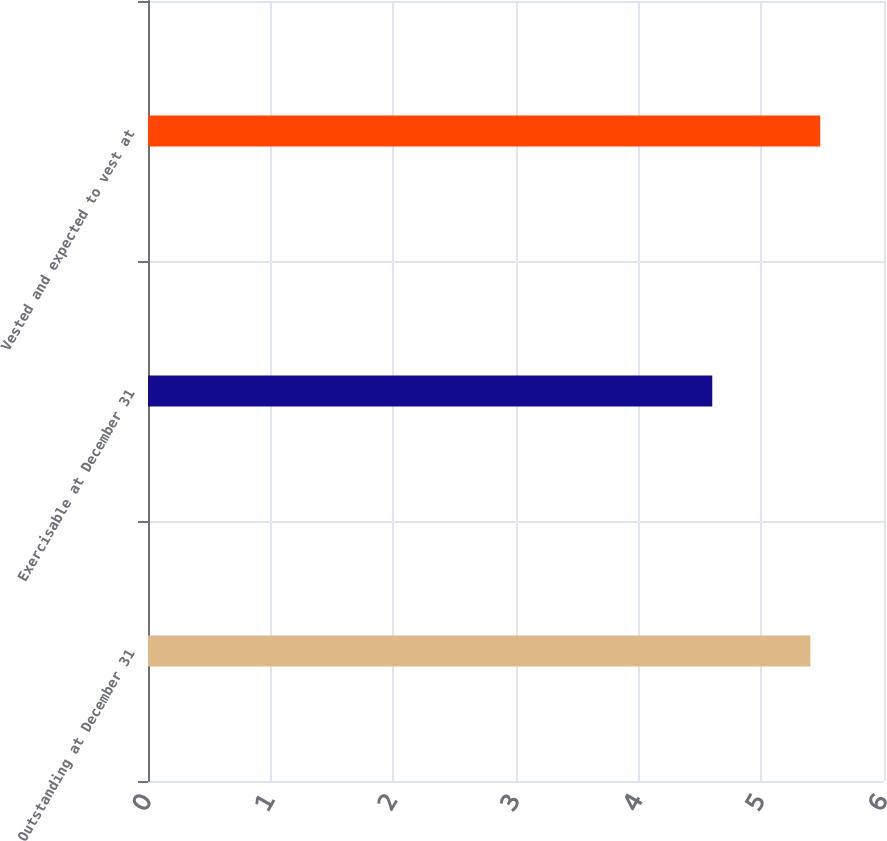<chart> <loc_0><loc_0><loc_500><loc_500><bar_chart><fcel>Outstanding at December 31<fcel>Exercisable at December 31<fcel>Vested and expected to vest at<nl><fcel>5.4<fcel>4.6<fcel>5.48<nl></chart> 